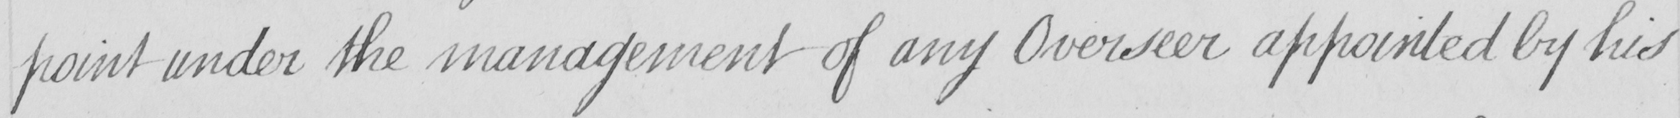What is written in this line of handwriting? -point under the management of any Overseer appointed by his 